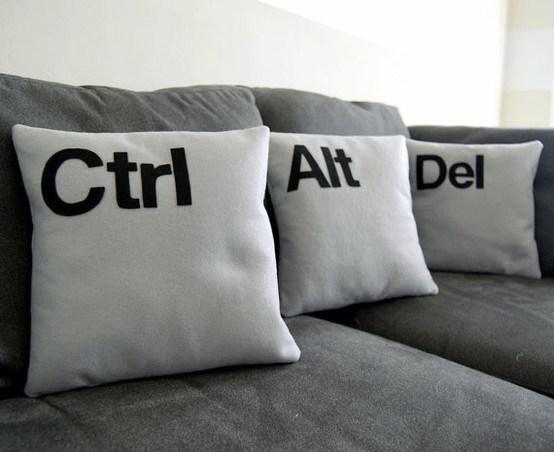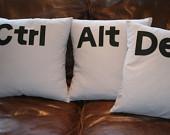The first image is the image on the left, the second image is the image on the right. Analyze the images presented: Is the assertion "Every throw pillow pictured is square and whitish with at least one black letter on it, and each image contains exactly three throw pillows." valid? Answer yes or no. Yes. The first image is the image on the left, the second image is the image on the right. Evaluate the accuracy of this statement regarding the images: "All of the pillows are computer related.". Is it true? Answer yes or no. Yes. 